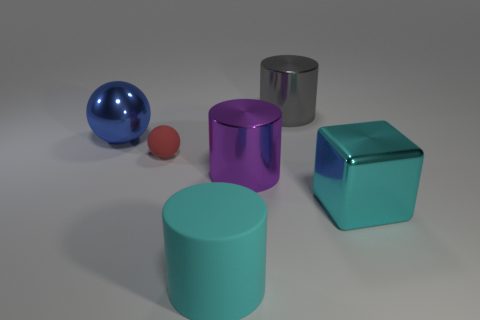Add 3 big cyan matte objects. How many objects exist? 9 Subtract all spheres. How many objects are left? 4 Subtract 0 green cylinders. How many objects are left? 6 Subtract all cyan cylinders. Subtract all small matte objects. How many objects are left? 4 Add 4 cyan cubes. How many cyan cubes are left? 5 Add 6 gray metal cylinders. How many gray metal cylinders exist? 7 